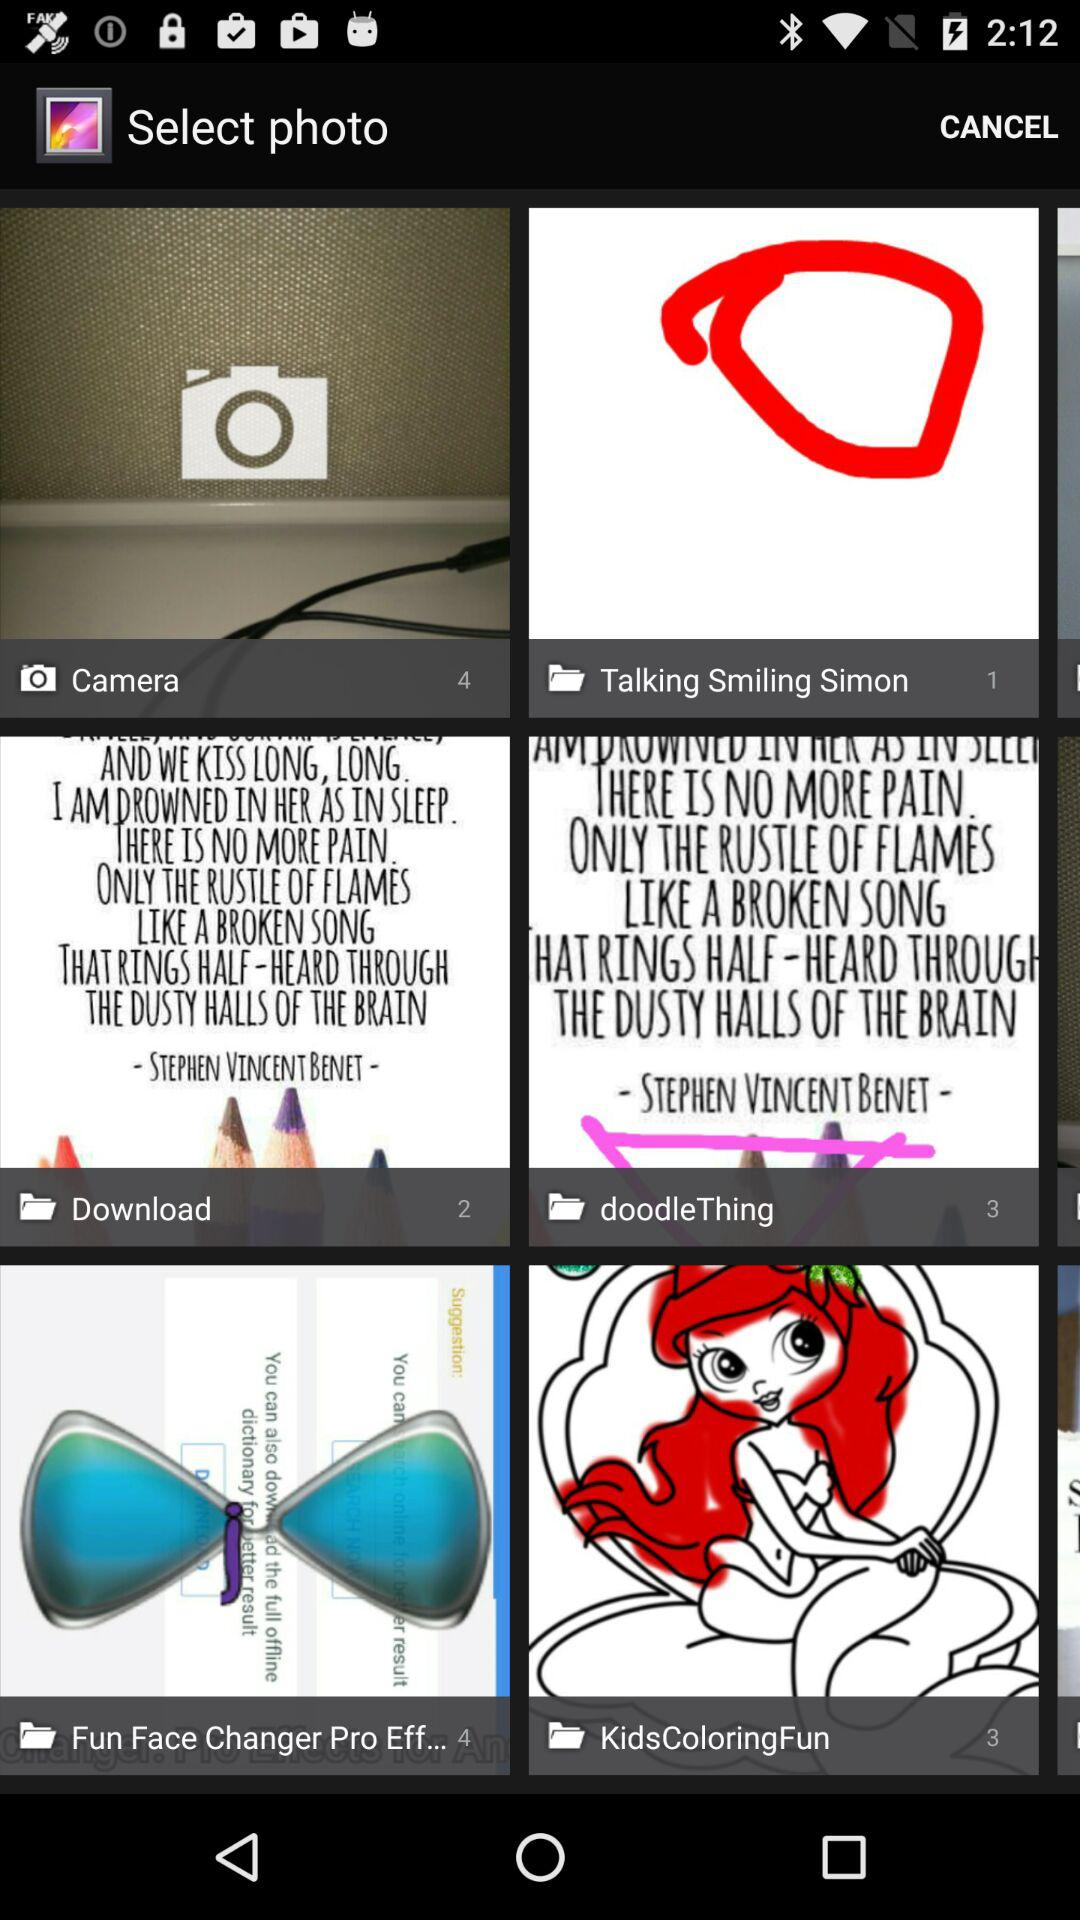How many photos are stored in "doodleThing" folder? The number of photos stored in "doodleThing" folder is 3. 